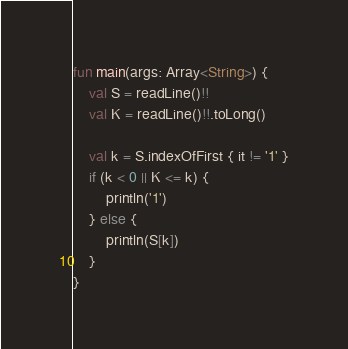<code> <loc_0><loc_0><loc_500><loc_500><_Kotlin_>fun main(args: Array<String>) {
    val S = readLine()!!
    val K = readLine()!!.toLong()

    val k = S.indexOfFirst { it != '1' }
    if (k < 0 || K <= k) {
        println('1')
    } else {
        println(S[k])
    }
}
</code> 